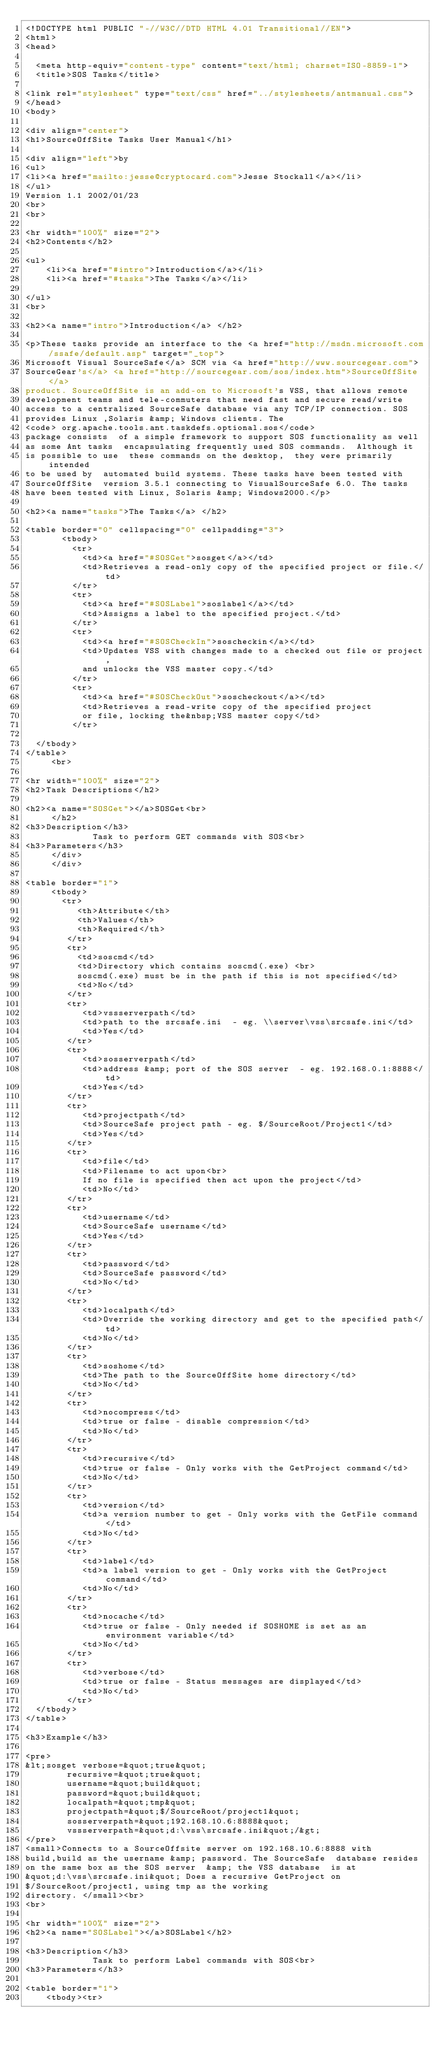<code> <loc_0><loc_0><loc_500><loc_500><_HTML_><!DOCTYPE html PUBLIC "-//W3C//DTD HTML 4.01 Transitional//EN">
<html>
<head>

  <meta http-equiv="content-type" content="text/html; charset=ISO-8859-1">
  <title>SOS Tasks</title>

<link rel="stylesheet" type="text/css" href="../stylesheets/antmanual.css">
</head>
<body>

<div align="center">
<h1>SourceOffSite Tasks User Manual</h1>

<div align="left">by
<ul>
<li><a href="mailto:jesse@cryptocard.com">Jesse Stockall</a></li>
</ul>
Version 1.1 2002/01/23
<br>
<br>

<hr width="100%" size="2">
<h2>Contents</h2>

<ul>
    <li><a href="#intro">Introduction</a></li>
    <li><a href="#tasks">The Tasks</a></li>

</ul>
<br>

<h2><a name="intro">Introduction</a> </h2>

<p>These tasks provide an interface to the <a href="http://msdn.microsoft.com/ssafe/default.asp" target="_top">
Microsoft Visual SourceSafe</a> SCM via <a href="http://www.sourcegear.com">
SourceGear's</a> <a href="http://sourcegear.com/sos/index.htm">SourceOffSite</a>
product. SourceOffSite is an add-on to Microsoft's VSS, that allows remote
development teams and tele-commuters that need fast and secure read/write
access to a centralized SourceSafe database via any TCP/IP connection. SOS
provides Linux ,Solaris &amp; Windows clients. The
<code> org.apache.tools.ant.taskdefs.optional.sos</code>
package consists  of a simple framework to support SOS functionality as well
as some Ant tasks  encapsulating frequently used SOS commands.  Although it
is possible to use  these commands on the desktop,  they were primarily intended
to be used by  automated build systems. These tasks have been tested with
SourceOffSite  version 3.5.1 connecting to VisualSourceSafe 6.0. The tasks
have been tested with Linux, Solaris &amp; Windows2000.</p>

<h2><a name="tasks">The Tasks</a> </h2>

<table border="0" cellspacing="0" cellpadding="3">
       <tbody>
         <tr>
           <td><a href="#SOSGet">sosget</a></td>
           <td>Retrieves a read-only copy of the specified project or file.</td>
         </tr>
         <tr>
           <td><a href="#SOSLabel">soslabel</a></td>
           <td>Assigns a label to the specified project.</td>
         </tr>
         <tr>
           <td><a href="#SOSCheckIn">soscheckin</a></td>
           <td>Updates VSS with changes made to a checked out file or project,
           and unlocks the VSS master copy.</td>
         </tr>
         <tr>
           <td><a href="#SOSCheckOut">soscheckout</a></td>
           <td>Retrieves a read-write copy of the specified project
           or file, locking the&nbsp;VSS master copy</td>
         </tr>

  </tbody>
</table>
     <br>

<hr width="100%" size="2">
<h2>Task Descriptions</h2>

<h2><a name="SOSGet"></a>SOSGet<br>
     </h2>
<h3>Description</h3>
             Task to perform GET commands with SOS<br>
<h3>Parameters</h3>
     </div>
     </div>

<table border="1">
     <tbody>
       <tr>
          <th>Attribute</th>
          <th>Values</th>
          <th>Required</th>
        </tr>
        <tr>
          <td>soscmd</td>
          <td>Directory which contains soscmd(.exe) <br>
          soscmd(.exe) must be in the path if this is not specified</td>
          <td>No</td>
        </tr>
        <tr>
           <td>vssserverpath</td>
           <td>path to the srcsafe.ini  - eg. \\server\vss\srcsafe.ini</td>
           <td>Yes</td>
        </tr>
        <tr>
           <td>sosserverpath</td>
           <td>address &amp; port of the SOS server  - eg. 192.168.0.1:8888</td>
           <td>Yes</td>
        </tr>
        <tr>
           <td>projectpath</td>
           <td>SourceSafe project path - eg. $/SourceRoot/Project1</td>
           <td>Yes</td>
        </tr>
        <tr>
           <td>file</td>
           <td>Filename to act upon<br>
           If no file is specified then act upon the project</td>
           <td>No</td>
        </tr>
        <tr>
           <td>username</td>
           <td>SourceSafe username</td>
           <td>Yes</td>
        </tr>
        <tr>
           <td>password</td>
           <td>SourceSafe password</td>
           <td>No</td>
        </tr>
        <tr>
           <td>localpath</td>
           <td>Override the working directory and get to the specified path</td>
           <td>No</td>
        </tr>
        <tr>
           <td>soshome</td>
           <td>The path to the SourceOffSite home directory</td>
           <td>No</td>
        </tr>
        <tr>
           <td>nocompress</td>
           <td>true or false - disable compression</td>
           <td>No</td>
        </tr>
        <tr>
           <td>recursive</td>
           <td>true or false - Only works with the GetProject command</td>
           <td>No</td>
        </tr>
        <tr>
           <td>version</td>
           <td>a version number to get - Only works with the GetFile command</td>
           <td>No</td>
        </tr>
        <tr>
           <td>label</td>
           <td>a label version to get - Only works with the GetProject command</td>
           <td>No</td>
        </tr>
        <tr>
           <td>nocache</td>
           <td>true or false - Only needed if SOSHOME is set as an environment variable</td>
           <td>No</td>
        </tr>
        <tr>
           <td>verbose</td>
           <td>true or false - Status messages are displayed</td>
           <td>No</td>
        </tr>
  </tbody>
</table>

<h3>Example</h3>

<pre>
&lt;sosget verbose=&quot;true&quot;
        recursive=&quot;true&quot;
        username=&quot;build&quot;
        password=&quot;build&quot;
        localpath=&quot;tmp&quot;
        projectpath=&quot;$/SourceRoot/project1&quot;
        sosserverpath=&quot;192.168.10.6:8888&quot;
        vssserverpath=&quot;d:\vss\srcsafe.ini&quot;/&gt;
</pre>
<small>Connects to a SourceOffsite server on 192.168.10.6:8888 with
build,build as the username &amp; password. The SourceSafe  database resides
on the same box as the SOS server  &amp; the VSS database  is at
&quot;d:\vss\srcsafe.ini&quot; Does a recursive GetProject on
$/SourceRoot/project1, using tmp as the working
directory. </small><br>
<br>

<hr width="100%" size="2">
<h2><a name="SOSLabel"></a>SOSLabel</h2>

<h3>Description</h3>
             Task to perform Label commands with SOS<br>
<h3>Parameters</h3>

<table border="1">
    <tbody><tr></code> 